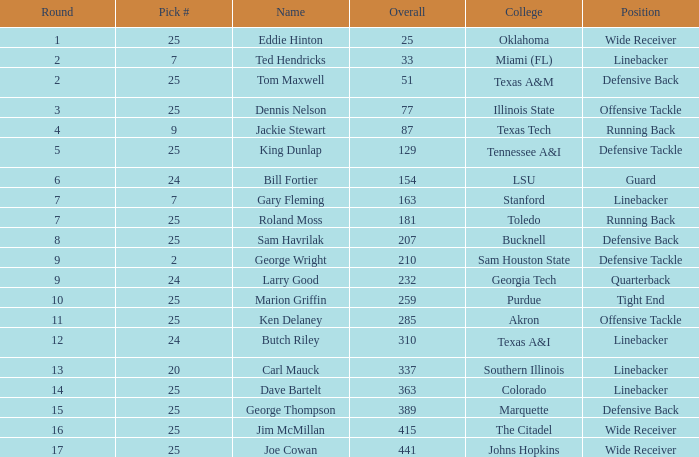Round smaller than 7, and an Overall of 129 is what college? Tennessee A&I. 